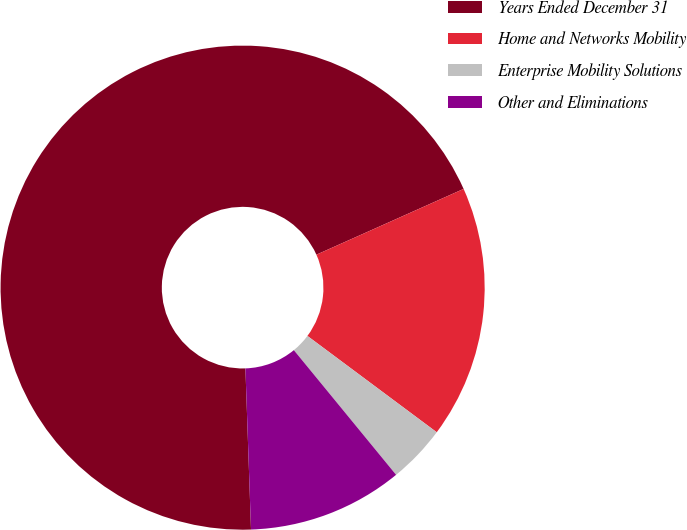Convert chart. <chart><loc_0><loc_0><loc_500><loc_500><pie_chart><fcel>Years Ended December 31<fcel>Home and Networks Mobility<fcel>Enterprise Mobility Solutions<fcel>Other and Eliminations<nl><fcel>68.87%<fcel>16.88%<fcel>3.88%<fcel>10.38%<nl></chart> 